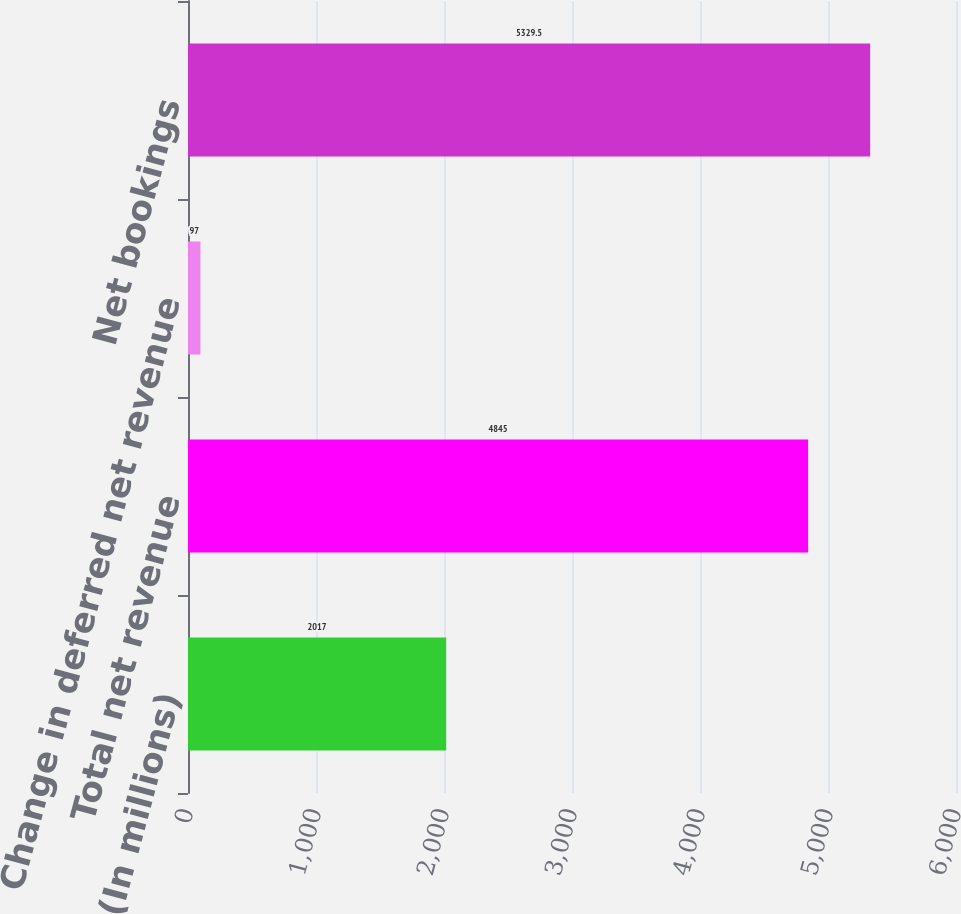<chart> <loc_0><loc_0><loc_500><loc_500><bar_chart><fcel>(In millions)<fcel>Total net revenue<fcel>Change in deferred net revenue<fcel>Net bookings<nl><fcel>2017<fcel>4845<fcel>97<fcel>5329.5<nl></chart> 